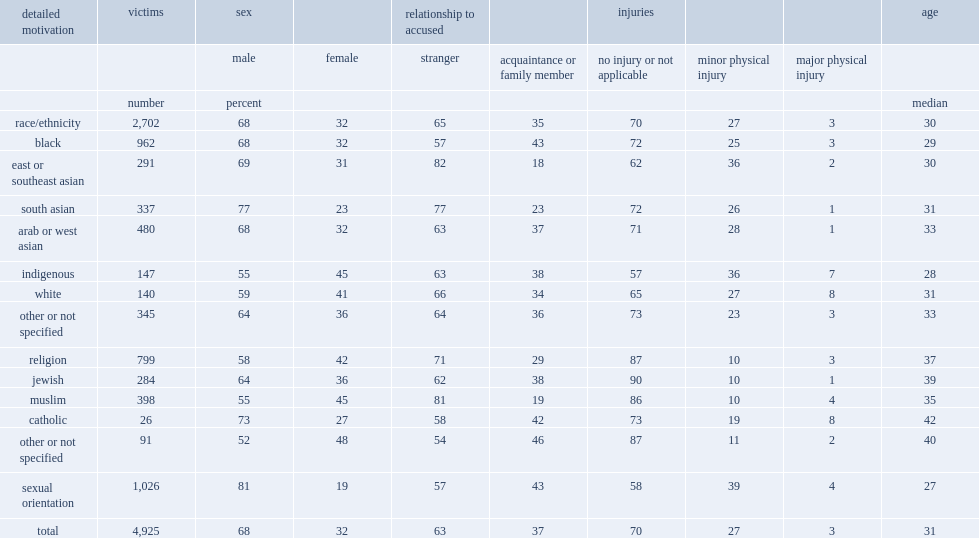For all types of hate crimes, what was the percentage of victims reported by police between 2010 and 2018 were female? 32.0. Of all victims of violent crimes targeting the muslim population that were reported to police, what was the percentage of women or girls? 45.0. What was the percentage of victims of hate crimes against the indigenous population? 45.0. More than any other type of hate crime, what was the percentage of victims of violent hate crime targeting sexual orientation were predominantly male? 81.0. What was the median age among the victims of violent hate crimes targeting the black population? 29.0. What was the median age for victims of violent crimes targeting religion? 37.0. What was the median age of all victims of violent hate crimes? 31.0. Which motivation did victims of violent hate crimes target were more likely to have resulted in injuries? Race/ethnicity. What the prevalence of victimization by someone known to them was highest among victims of hate crimes targeting the black population? 43.0. What the prevalence of victimization by someone known to them was highest among victims of hate crimes targeting sexual orientation? 43.0. 